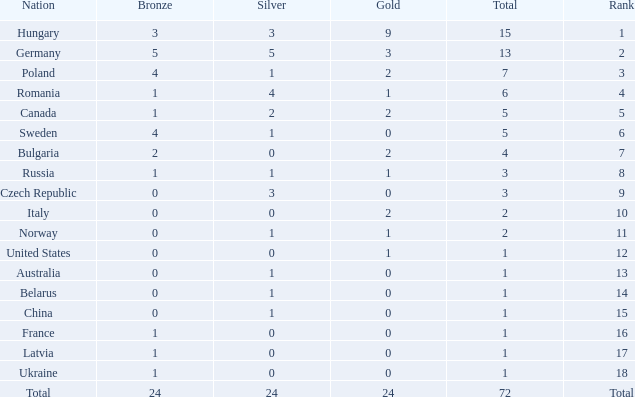What nation has 0 as the silver, 1 as the bronze, with 18 as the rank? Ukraine. 